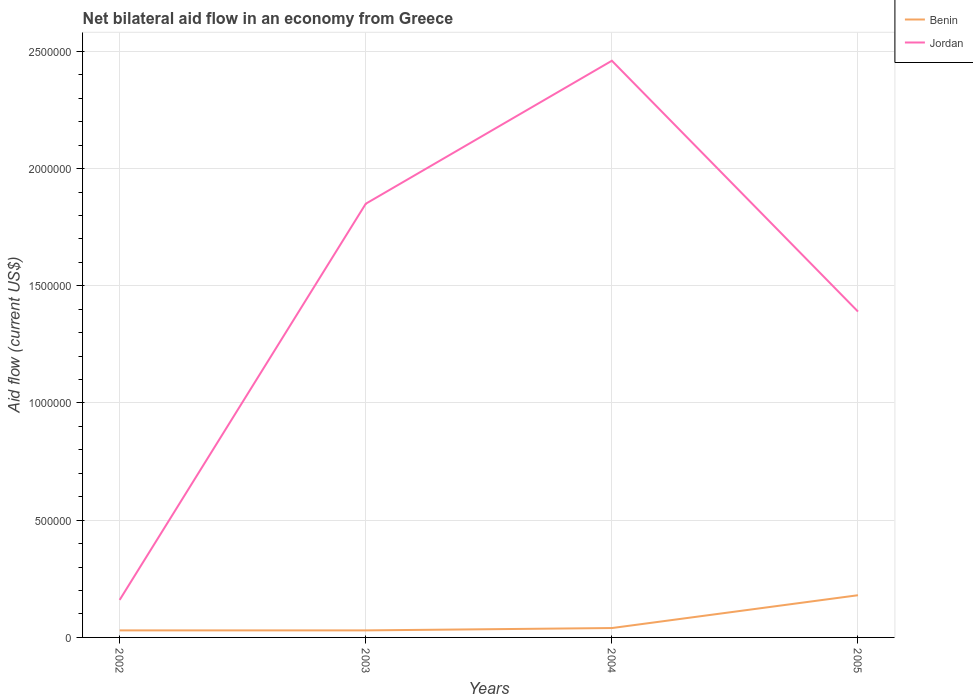How many different coloured lines are there?
Provide a succinct answer. 2. Across all years, what is the maximum net bilateral aid flow in Benin?
Your answer should be very brief. 3.00e+04. In which year was the net bilateral aid flow in Benin maximum?
Ensure brevity in your answer.  2002. What is the total net bilateral aid flow in Jordan in the graph?
Your answer should be very brief. -6.10e+05. What is the difference between the highest and the second highest net bilateral aid flow in Jordan?
Your answer should be very brief. 2.30e+06. What is the difference between the highest and the lowest net bilateral aid flow in Benin?
Your answer should be very brief. 1. How many lines are there?
Provide a succinct answer. 2. What is the difference between two consecutive major ticks on the Y-axis?
Your response must be concise. 5.00e+05. Are the values on the major ticks of Y-axis written in scientific E-notation?
Your answer should be compact. No. Where does the legend appear in the graph?
Give a very brief answer. Top right. How are the legend labels stacked?
Make the answer very short. Vertical. What is the title of the graph?
Make the answer very short. Net bilateral aid flow in an economy from Greece. Does "Tonga" appear as one of the legend labels in the graph?
Ensure brevity in your answer.  No. What is the Aid flow (current US$) of Benin in 2003?
Your response must be concise. 3.00e+04. What is the Aid flow (current US$) in Jordan in 2003?
Ensure brevity in your answer.  1.85e+06. What is the Aid flow (current US$) of Benin in 2004?
Offer a terse response. 4.00e+04. What is the Aid flow (current US$) in Jordan in 2004?
Your answer should be compact. 2.46e+06. What is the Aid flow (current US$) of Jordan in 2005?
Your response must be concise. 1.39e+06. Across all years, what is the maximum Aid flow (current US$) of Jordan?
Ensure brevity in your answer.  2.46e+06. Across all years, what is the minimum Aid flow (current US$) of Benin?
Keep it short and to the point. 3.00e+04. Across all years, what is the minimum Aid flow (current US$) in Jordan?
Your answer should be compact. 1.60e+05. What is the total Aid flow (current US$) in Jordan in the graph?
Provide a short and direct response. 5.86e+06. What is the difference between the Aid flow (current US$) of Benin in 2002 and that in 2003?
Offer a very short reply. 0. What is the difference between the Aid flow (current US$) in Jordan in 2002 and that in 2003?
Provide a succinct answer. -1.69e+06. What is the difference between the Aid flow (current US$) in Jordan in 2002 and that in 2004?
Make the answer very short. -2.30e+06. What is the difference between the Aid flow (current US$) in Jordan in 2002 and that in 2005?
Your answer should be very brief. -1.23e+06. What is the difference between the Aid flow (current US$) of Benin in 2003 and that in 2004?
Provide a short and direct response. -10000. What is the difference between the Aid flow (current US$) in Jordan in 2003 and that in 2004?
Your answer should be compact. -6.10e+05. What is the difference between the Aid flow (current US$) in Benin in 2003 and that in 2005?
Provide a succinct answer. -1.50e+05. What is the difference between the Aid flow (current US$) of Benin in 2004 and that in 2005?
Keep it short and to the point. -1.40e+05. What is the difference between the Aid flow (current US$) in Jordan in 2004 and that in 2005?
Make the answer very short. 1.07e+06. What is the difference between the Aid flow (current US$) of Benin in 2002 and the Aid flow (current US$) of Jordan in 2003?
Keep it short and to the point. -1.82e+06. What is the difference between the Aid flow (current US$) of Benin in 2002 and the Aid flow (current US$) of Jordan in 2004?
Provide a short and direct response. -2.43e+06. What is the difference between the Aid flow (current US$) in Benin in 2002 and the Aid flow (current US$) in Jordan in 2005?
Ensure brevity in your answer.  -1.36e+06. What is the difference between the Aid flow (current US$) of Benin in 2003 and the Aid flow (current US$) of Jordan in 2004?
Your answer should be compact. -2.43e+06. What is the difference between the Aid flow (current US$) of Benin in 2003 and the Aid flow (current US$) of Jordan in 2005?
Ensure brevity in your answer.  -1.36e+06. What is the difference between the Aid flow (current US$) in Benin in 2004 and the Aid flow (current US$) in Jordan in 2005?
Keep it short and to the point. -1.35e+06. What is the average Aid flow (current US$) in Jordan per year?
Your answer should be compact. 1.46e+06. In the year 2003, what is the difference between the Aid flow (current US$) in Benin and Aid flow (current US$) in Jordan?
Keep it short and to the point. -1.82e+06. In the year 2004, what is the difference between the Aid flow (current US$) in Benin and Aid flow (current US$) in Jordan?
Make the answer very short. -2.42e+06. In the year 2005, what is the difference between the Aid flow (current US$) in Benin and Aid flow (current US$) in Jordan?
Offer a very short reply. -1.21e+06. What is the ratio of the Aid flow (current US$) in Benin in 2002 to that in 2003?
Provide a succinct answer. 1. What is the ratio of the Aid flow (current US$) in Jordan in 2002 to that in 2003?
Offer a terse response. 0.09. What is the ratio of the Aid flow (current US$) of Benin in 2002 to that in 2004?
Offer a terse response. 0.75. What is the ratio of the Aid flow (current US$) in Jordan in 2002 to that in 2004?
Provide a succinct answer. 0.07. What is the ratio of the Aid flow (current US$) of Benin in 2002 to that in 2005?
Make the answer very short. 0.17. What is the ratio of the Aid flow (current US$) of Jordan in 2002 to that in 2005?
Make the answer very short. 0.12. What is the ratio of the Aid flow (current US$) of Benin in 2003 to that in 2004?
Offer a terse response. 0.75. What is the ratio of the Aid flow (current US$) in Jordan in 2003 to that in 2004?
Your answer should be very brief. 0.75. What is the ratio of the Aid flow (current US$) in Benin in 2003 to that in 2005?
Your answer should be very brief. 0.17. What is the ratio of the Aid flow (current US$) in Jordan in 2003 to that in 2005?
Keep it short and to the point. 1.33. What is the ratio of the Aid flow (current US$) in Benin in 2004 to that in 2005?
Make the answer very short. 0.22. What is the ratio of the Aid flow (current US$) of Jordan in 2004 to that in 2005?
Your answer should be very brief. 1.77. What is the difference between the highest and the second highest Aid flow (current US$) in Benin?
Provide a succinct answer. 1.40e+05. What is the difference between the highest and the lowest Aid flow (current US$) in Jordan?
Offer a terse response. 2.30e+06. 